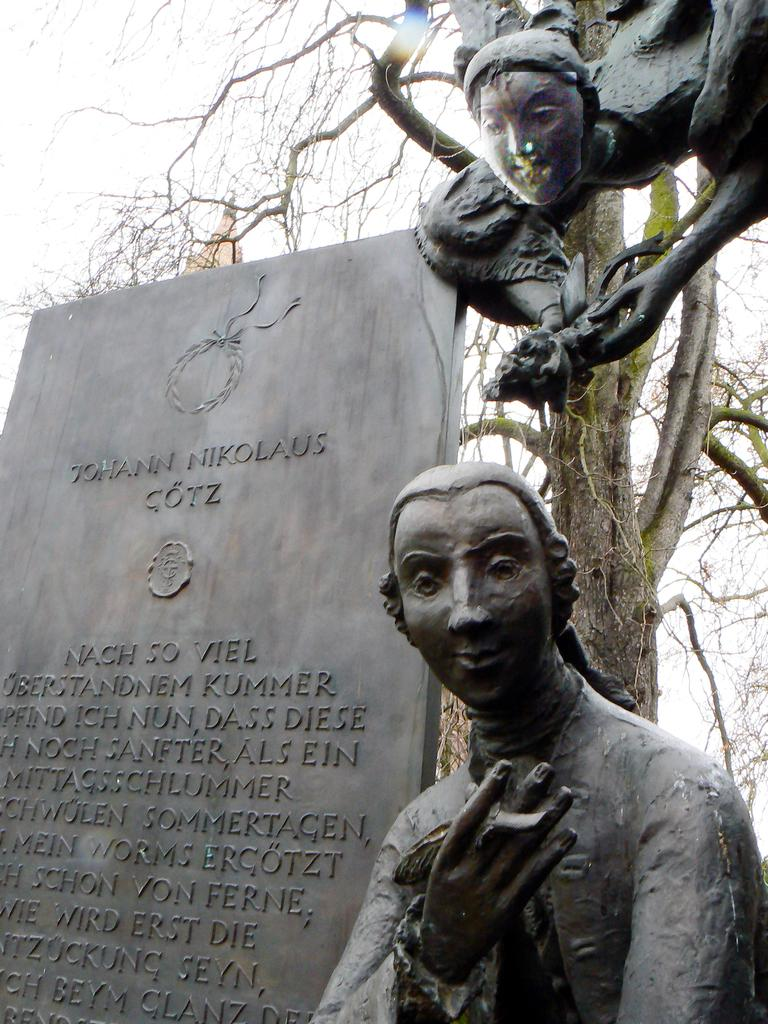What is written on in the image? There is writing on a stone in the image. What type of objects can be seen in the image besides the stone? There are sculptures in the image. What type of plant is visible in the image? There is a tree visible in the image. What type of beef is being served at the art exhibit in the image? There is no mention of beef or an art exhibit in the image; it features writing on a stone, sculptures, and a tree. 